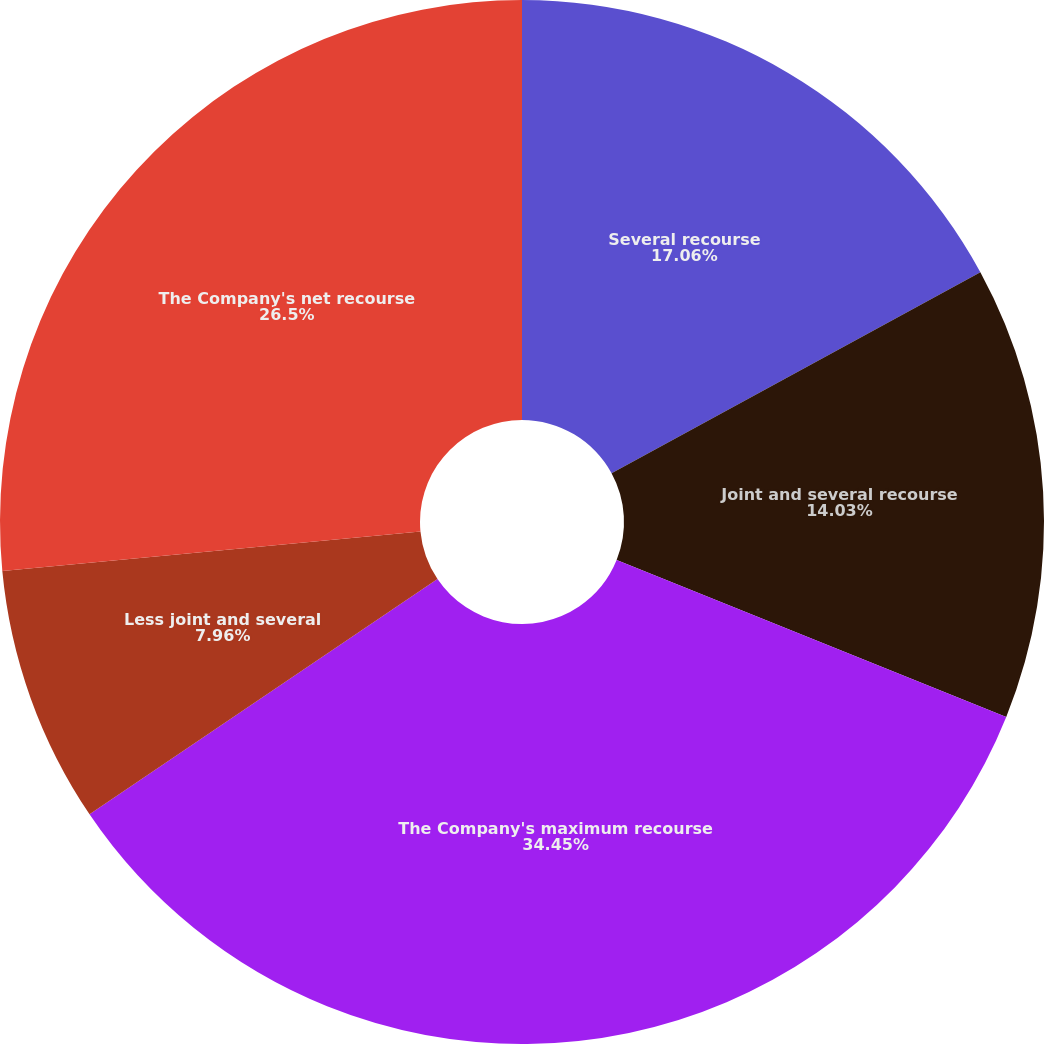Convert chart. <chart><loc_0><loc_0><loc_500><loc_500><pie_chart><fcel>Several recourse<fcel>Joint and several recourse<fcel>The Company's maximum recourse<fcel>Less joint and several<fcel>The Company's net recourse<nl><fcel>17.06%<fcel>14.03%<fcel>34.45%<fcel>7.96%<fcel>26.5%<nl></chart> 